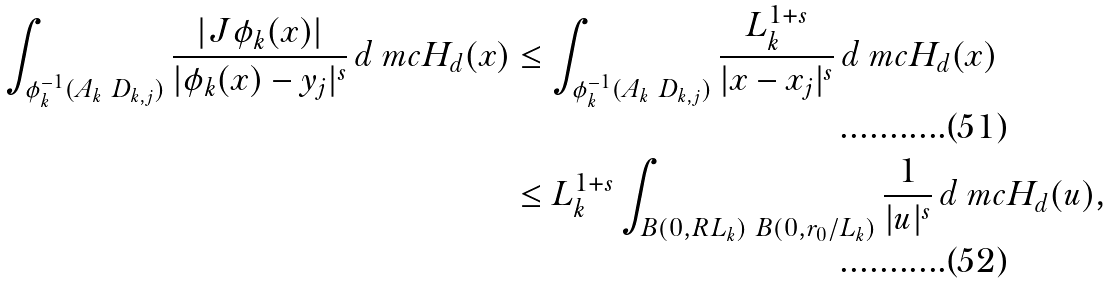Convert formula to latex. <formula><loc_0><loc_0><loc_500><loc_500>\int _ { \phi _ { k } ^ { - 1 } ( A _ { k } \ D _ { k , j } ) } \frac { | J \phi _ { k } ( x ) | } { | \phi _ { k } ( x ) - y _ { j } | ^ { s } } \, d \ m c { H } _ { d } ( x ) & \leq \int _ { \phi _ { k } ^ { - 1 } ( A _ { k } \ D _ { k , j } ) } \frac { L _ { k } ^ { 1 + s } } { | x - x _ { j } | ^ { s } } \, d \ m c { H } _ { d } ( x ) \\ & \leq L _ { k } ^ { 1 + s } \int _ { B ( 0 , R L _ { k } ) \ B ( 0 , r _ { 0 } / L _ { k } ) } \frac { 1 } { | u | ^ { s } } \, d \ m c { H } _ { d } ( u ) ,</formula> 